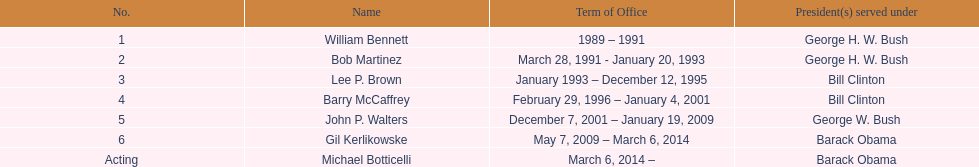How long did the first director serve in office? 2 years. 